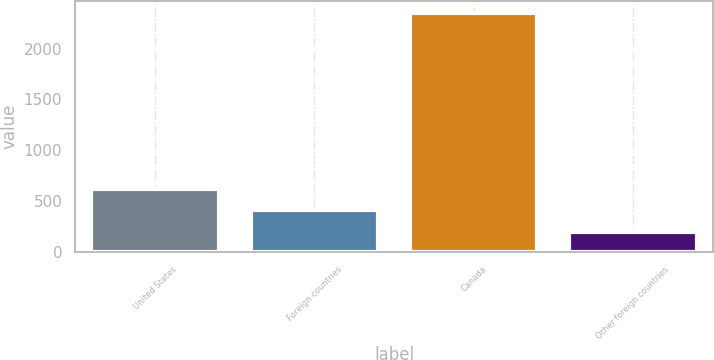Convert chart to OTSL. <chart><loc_0><loc_0><loc_500><loc_500><bar_chart><fcel>United States<fcel>Foreign countries<fcel>Canada<fcel>Other foreign countries<nl><fcel>622.2<fcel>406.1<fcel>2351<fcel>190<nl></chart> 